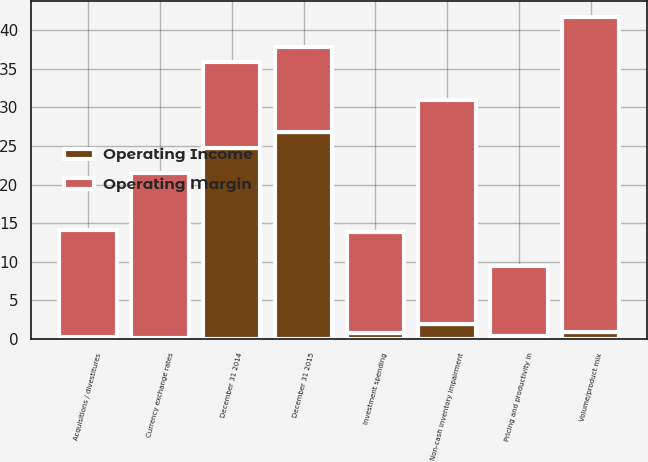Convert chart to OTSL. <chart><loc_0><loc_0><loc_500><loc_500><stacked_bar_chart><ecel><fcel>December 31 2014<fcel>Pricing and productivity in<fcel>Volume/product mix<fcel>Non-cash inventory impairment<fcel>Currency exchange rates<fcel>Investment spending<fcel>Acquisitions / divestitures<fcel>December 31 2015<nl><fcel>Operating Margin<fcel>11.05<fcel>9.1<fcel>40.8<fcel>29.1<fcel>21.4<fcel>13<fcel>13.8<fcel>11.05<nl><fcel>Operating Income<fcel>24.8<fcel>0.4<fcel>0.9<fcel>1.9<fcel>0.1<fcel>0.8<fcel>0.3<fcel>26.8<nl></chart> 